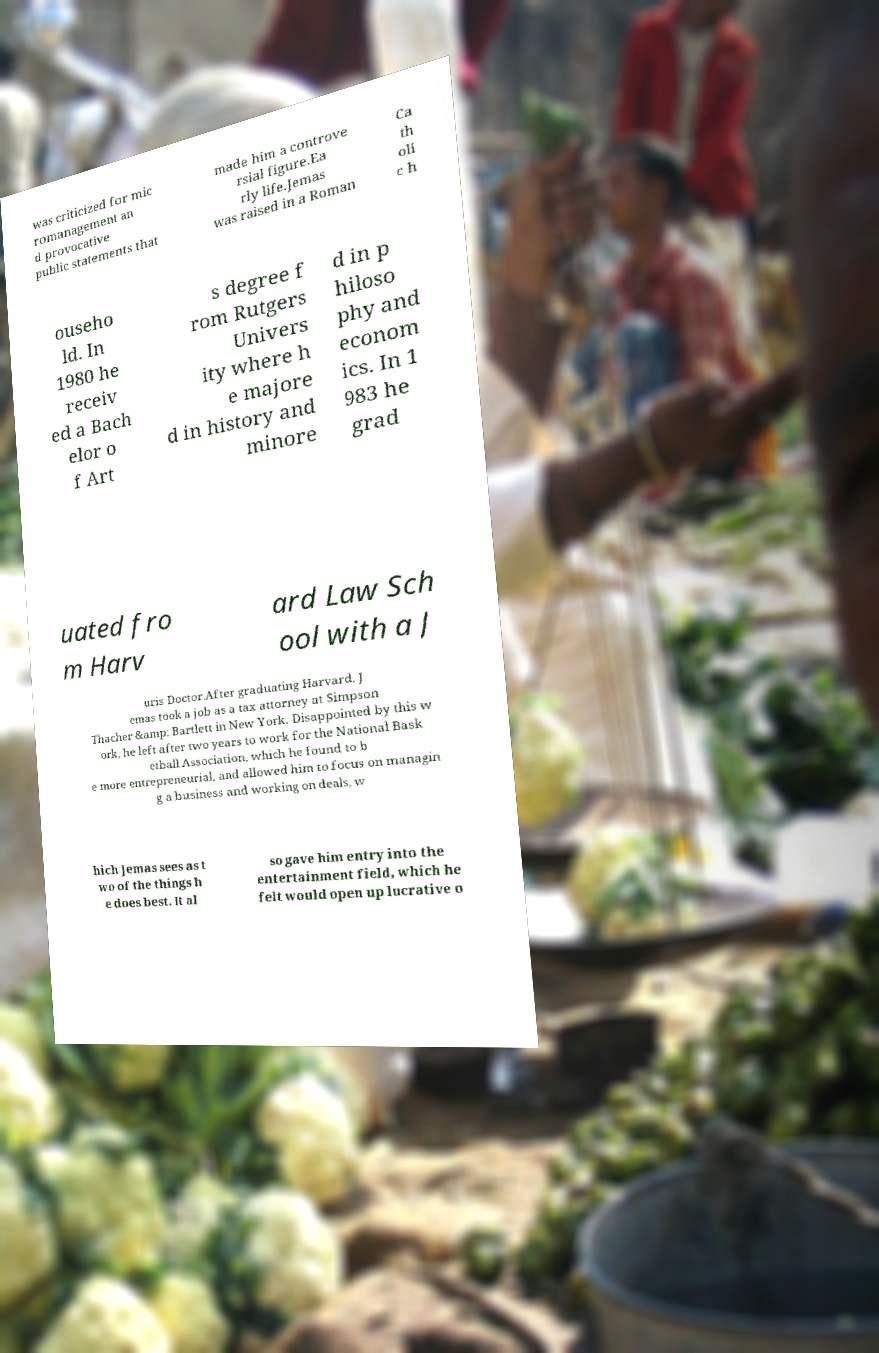Please identify and transcribe the text found in this image. was criticized for mic romanagement an d provocative public statements that made him a controve rsial figure.Ea rly life.Jemas was raised in a Roman Ca th oli c h ouseho ld. In 1980 he receiv ed a Bach elor o f Art s degree f rom Rutgers Univers ity where h e majore d in history and minore d in p hiloso phy and econom ics. In 1 983 he grad uated fro m Harv ard Law Sch ool with a J uris Doctor.After graduating Harvard, J emas took a job as a tax attorney at Simpson Thacher &amp; Bartlett in New York. Disappointed by this w ork, he left after two years to work for the National Bask etball Association, which he found to b e more entrepreneurial, and allowed him to focus on managin g a business and working on deals, w hich Jemas sees as t wo of the things h e does best. It al so gave him entry into the entertainment field, which he felt would open up lucrative o 